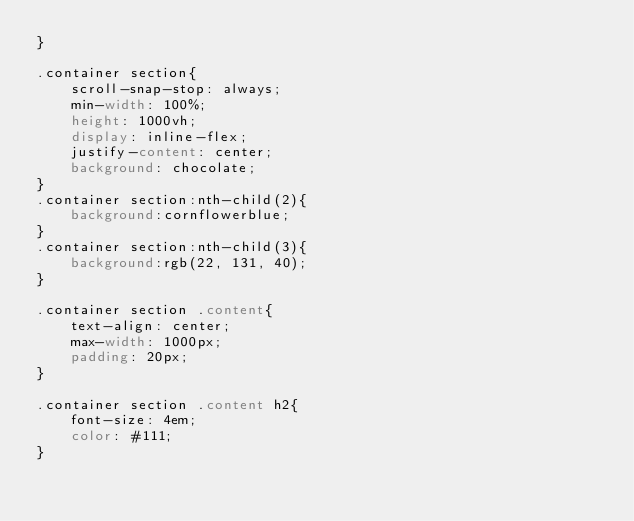<code> <loc_0><loc_0><loc_500><loc_500><_CSS_>}

.container section{
    scroll-snap-stop: always;
    min-width: 100%;
    height: 1000vh;
    display: inline-flex;
    justify-content: center;
    background: chocolate;
}
.container section:nth-child(2){
    background:cornflowerblue;
}
.container section:nth-child(3){
    background:rgb(22, 131, 40);
}

.container section .content{
    text-align: center;
    max-width: 1000px;
    padding: 20px;
}

.container section .content h2{
    font-size: 4em;
    color: #111;
}

</code> 